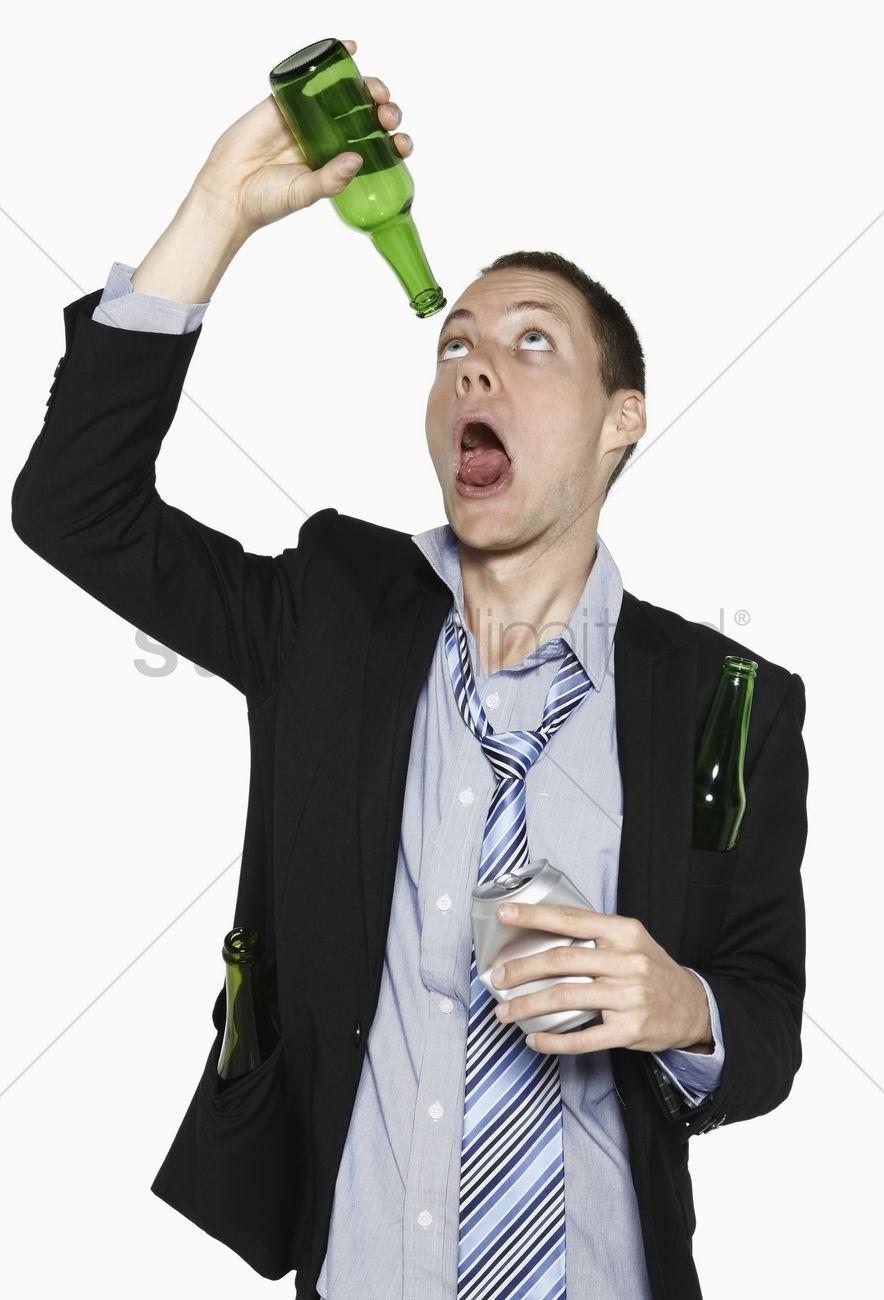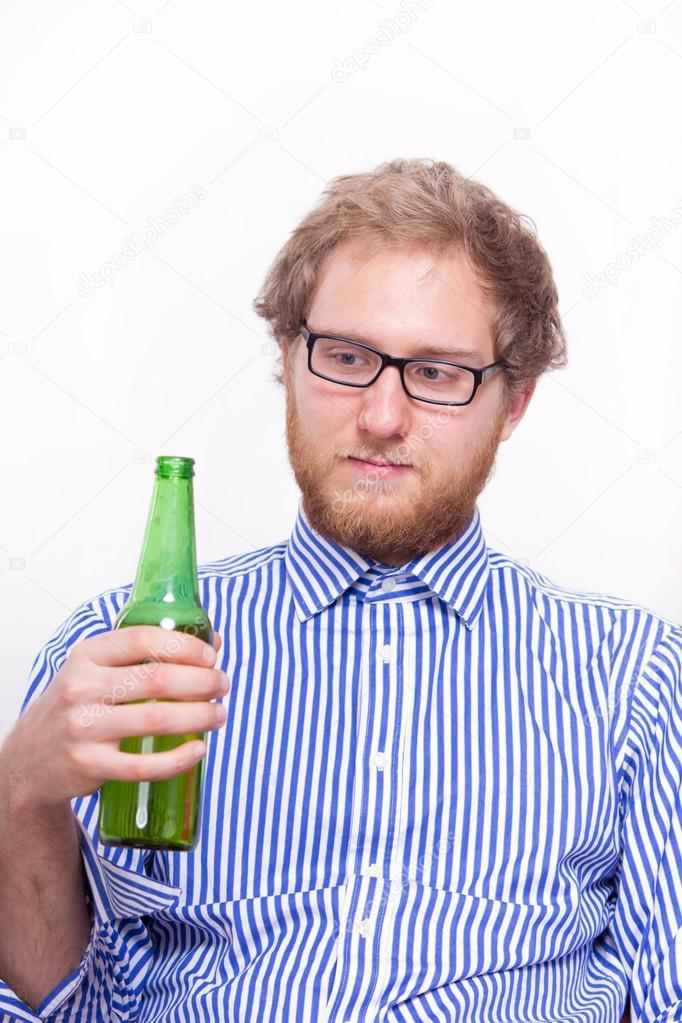The first image is the image on the left, the second image is the image on the right. For the images displayed, is the sentence "There are two guys drinking what appears to be beer." factually correct? Answer yes or no. No. The first image is the image on the left, the second image is the image on the right. For the images shown, is this caption "The left image shows a man leaning his head back to drink from a brown bottle held in one hand, while the other unraised hand holds another brown bottle." true? Answer yes or no. No. 